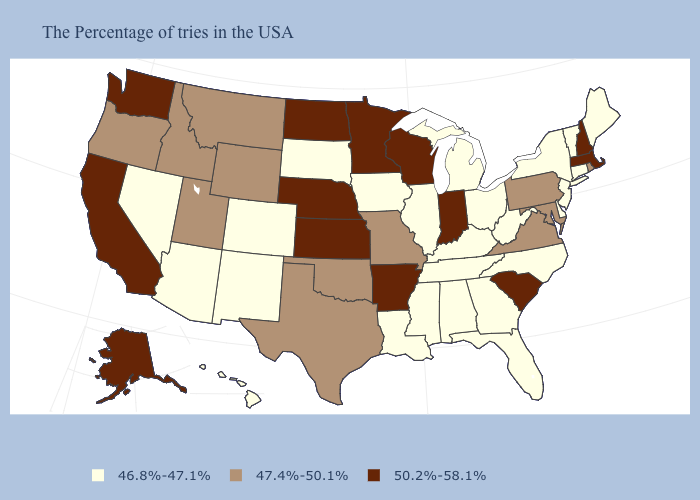Does Massachusetts have the highest value in the USA?
Be succinct. Yes. Among the states that border South Dakota , does Nebraska have the highest value?
Write a very short answer. Yes. What is the lowest value in the USA?
Write a very short answer. 46.8%-47.1%. What is the lowest value in states that border Ohio?
Answer briefly. 46.8%-47.1%. Name the states that have a value in the range 46.8%-47.1%?
Keep it brief. Maine, Vermont, Connecticut, New York, New Jersey, Delaware, North Carolina, West Virginia, Ohio, Florida, Georgia, Michigan, Kentucky, Alabama, Tennessee, Illinois, Mississippi, Louisiana, Iowa, South Dakota, Colorado, New Mexico, Arizona, Nevada, Hawaii. How many symbols are there in the legend?
Answer briefly. 3. Name the states that have a value in the range 50.2%-58.1%?
Be succinct. Massachusetts, New Hampshire, South Carolina, Indiana, Wisconsin, Arkansas, Minnesota, Kansas, Nebraska, North Dakota, California, Washington, Alaska. Among the states that border Idaho , which have the lowest value?
Be succinct. Nevada. Does the map have missing data?
Concise answer only. No. Name the states that have a value in the range 47.4%-50.1%?
Write a very short answer. Rhode Island, Maryland, Pennsylvania, Virginia, Missouri, Oklahoma, Texas, Wyoming, Utah, Montana, Idaho, Oregon. What is the value of Pennsylvania?
Quick response, please. 47.4%-50.1%. Which states have the lowest value in the USA?
Keep it brief. Maine, Vermont, Connecticut, New York, New Jersey, Delaware, North Carolina, West Virginia, Ohio, Florida, Georgia, Michigan, Kentucky, Alabama, Tennessee, Illinois, Mississippi, Louisiana, Iowa, South Dakota, Colorado, New Mexico, Arizona, Nevada, Hawaii. Is the legend a continuous bar?
Short answer required. No. Does New Jersey have the lowest value in the USA?
Write a very short answer. Yes. 